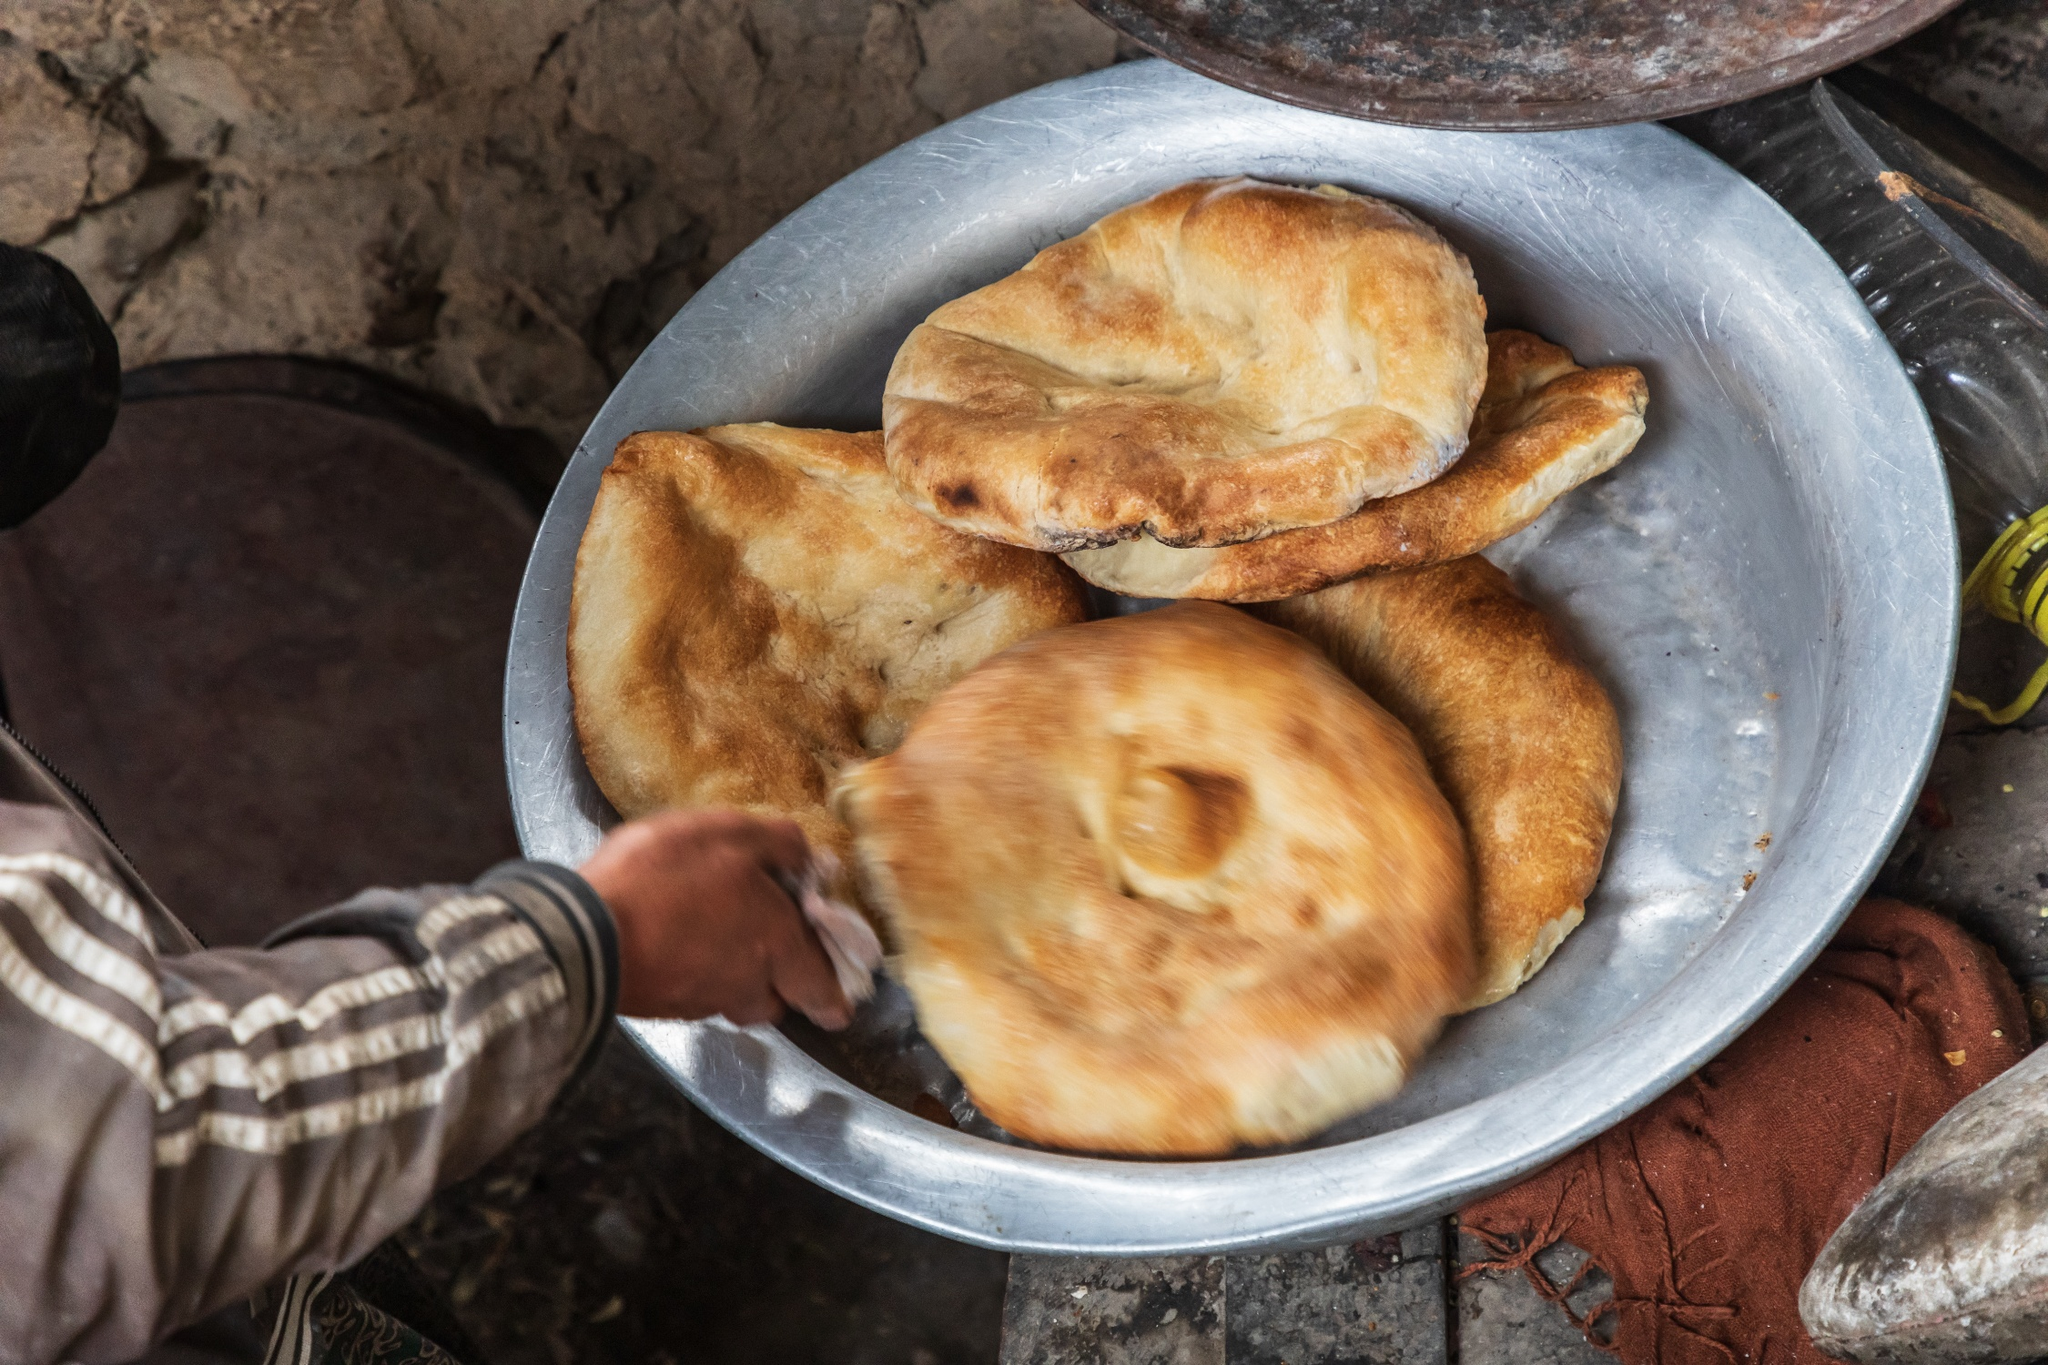What can you infer about the setting and activity in this image? The image suggests a humble but warmly inviting setting, likely in a rural or rustic environment. The person’s hand and the casual arrangement of freshly baked bread on a metal plate imply a moment of meal preparation or serving. The presence of the oil bottle correlates with cooking or food enhancement. The overall feel is of simplicity, daily routine, and the comfort of homemade food. Describe the atmosphere conveyed by the image. The atmosphere conveyed by the image is warm and homely. The simple, unadorned surroundings combined with the freshly baked bread suggest a sense of comfort and tradition. This image captures a moment of everyday life, where food acts as a focal point for bringing people together. The blurred background adds depth, highlighting the bread and the hand, which creates an intimate feel. Imagine a story behind this image. What could it be? In a serene village nestled among rolling hills, an old man named Ahmed prepares for the annual harvest festival. For months, he had been honing his bread-making skills to perfection. Today, Ahmed bakes his finest batch, filled with nostalgia and family recipes passed down through generations. As he tenderly transfers the golden bread onto the metal plate, he recalls his mother’s teachings and smiles, knowing he is preserving a cherished heritage. The oil bottle nearby, a remnant of his father’s craftsmanship, stands as a token of love and continued tradition. The festival later that day will see villagers savoring his bread, not just as food, but as a shared symbol of their community's heart and history. What might be the significance of the bread in this image? The bread in this image signifies more than just food. It represents tradition, family heritage, and the simplicity of rural life. The act of baking and serving bread is often tied to care and nourishment. In many cultures, bread is a staple and symbolizes sustenance and sharing. Here, the golden hue and fresh appearance of the bread suggest it is a lovingly prepared dish, potentially for a special occasion or a communal meal. It embodies warmth, effort, and the comforts of home. 